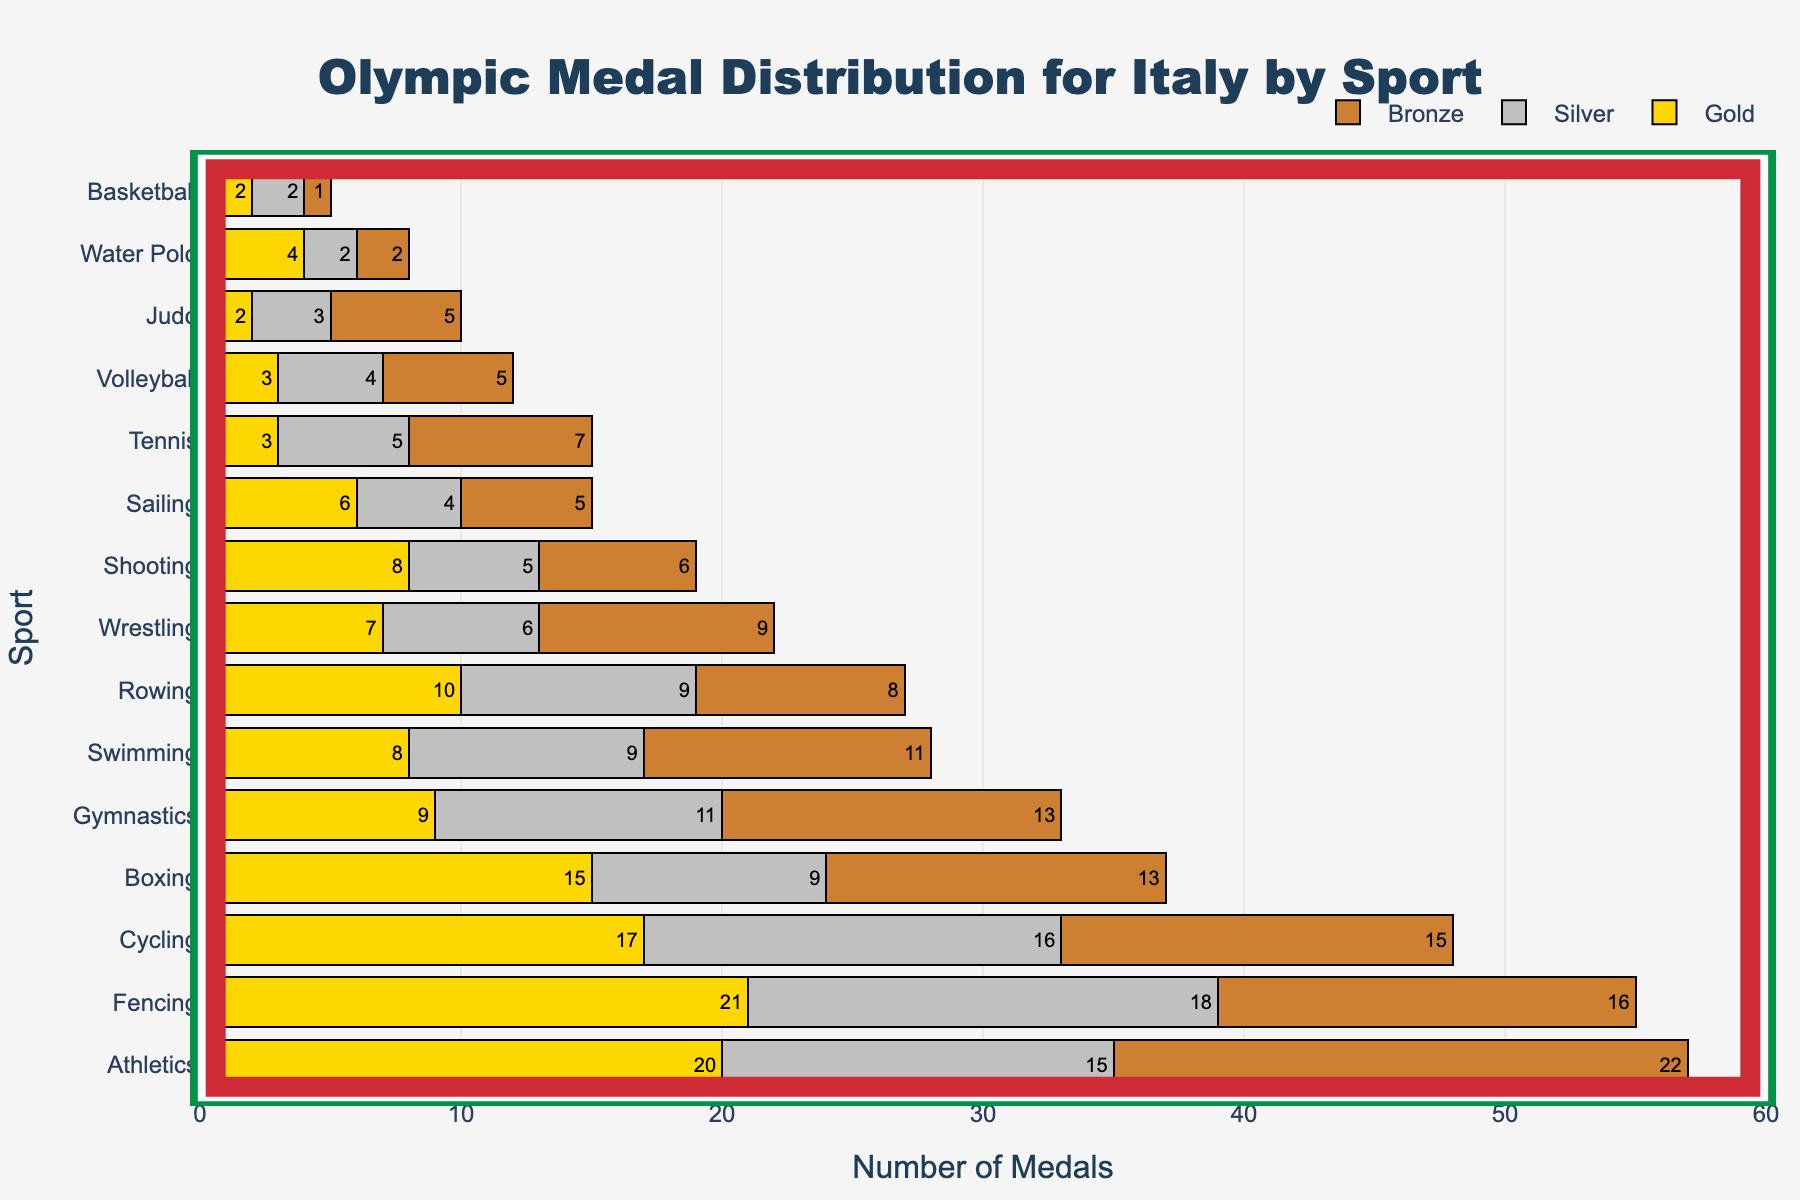What's the title of the figure? The title is usually located at the top of the figure, and it summarizes the theme of the chart. This title provides an overview of what the figure is about.
Answer: Olympic Medal Distribution for Italy by Sport What is the total number of gold medals won by Italy in Athletics? The 'Athletics' row contains the breakdown of gold, silver, and bronze medals. By looking at the gold medal count for Athletics directly, we find the value.
Answer: 20 Which sport has the highest total number of medals? To determine this, you need to look at the sums of gold, silver, and bronze medals for each sport and identify the sport with the highest total. This could also be interpreted by looking at the top of the bars in a sorted fan chart.
Answer: Fencing What is the combined total of medals won in Cycling and Rowing? Add up the total medals for both Cycling and Rowing. Cycling has 48 total medals, and Rowing has 27 total medals. So, their combined total is 48 + 27 = 75
Answer: 75 What percentage of the total medals in Wrestling are silver? Calculate the percentage by taking the number of silver medals in Wrestling and dividing it by the total number of medals in Wrestling, then multiply by 100. (6 / 22) * 100 ≈ 27.27%
Answer: 27.27% How many total medals were won in Gymnastics and Shooting combined in Italy? Sum the total medals for Gymnastics (33) with those won in Shooting (19). 33 + 19 = 52
Answer: 52 Compare the total number of bronze medals won in Athletics and Swimming. Which sport has more and by how much? Athletics has 22 bronze medals and Swimming has 11. Subtract the two to find the difference. 22 - 11 = 11
Answer: Athletics by 11 How many more total medals does Italy have in Boxing than in Judo? Boxing has 37 total medals, while Judo has 10. Find the difference by subtracting the total for Judo from the total for Boxing. 37 - 10 = 27
Answer: 27 